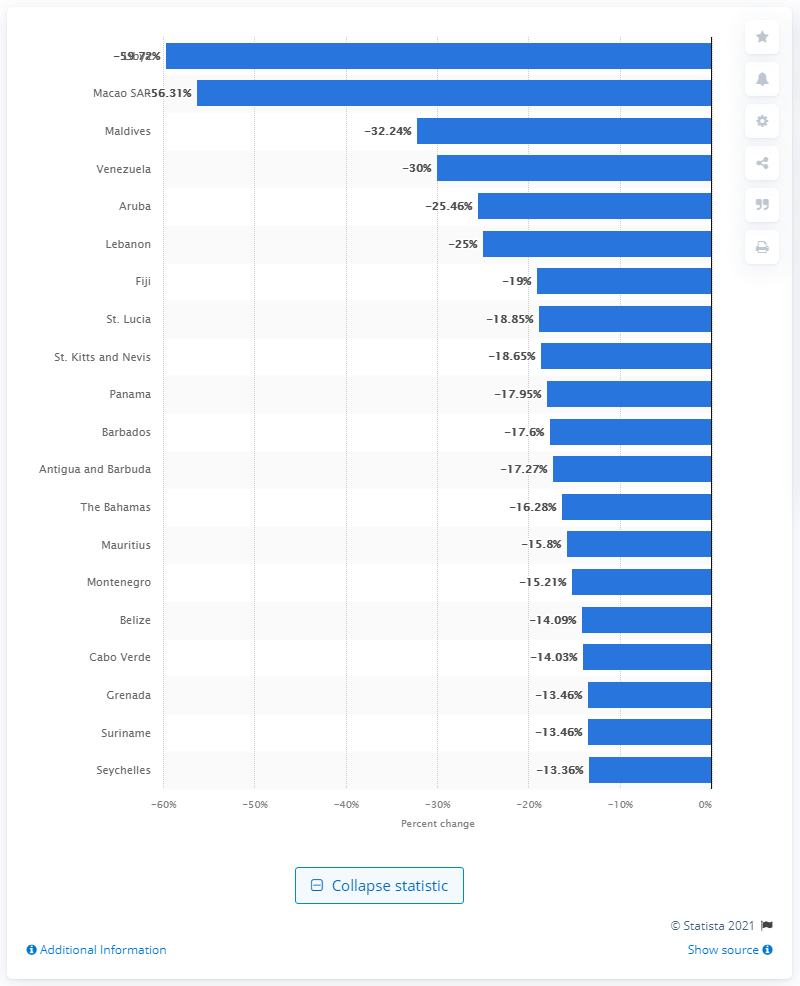Indicate a few pertinent items in this graphic. Libya ranked first among countries with the highest GDP decrease in 2020. 